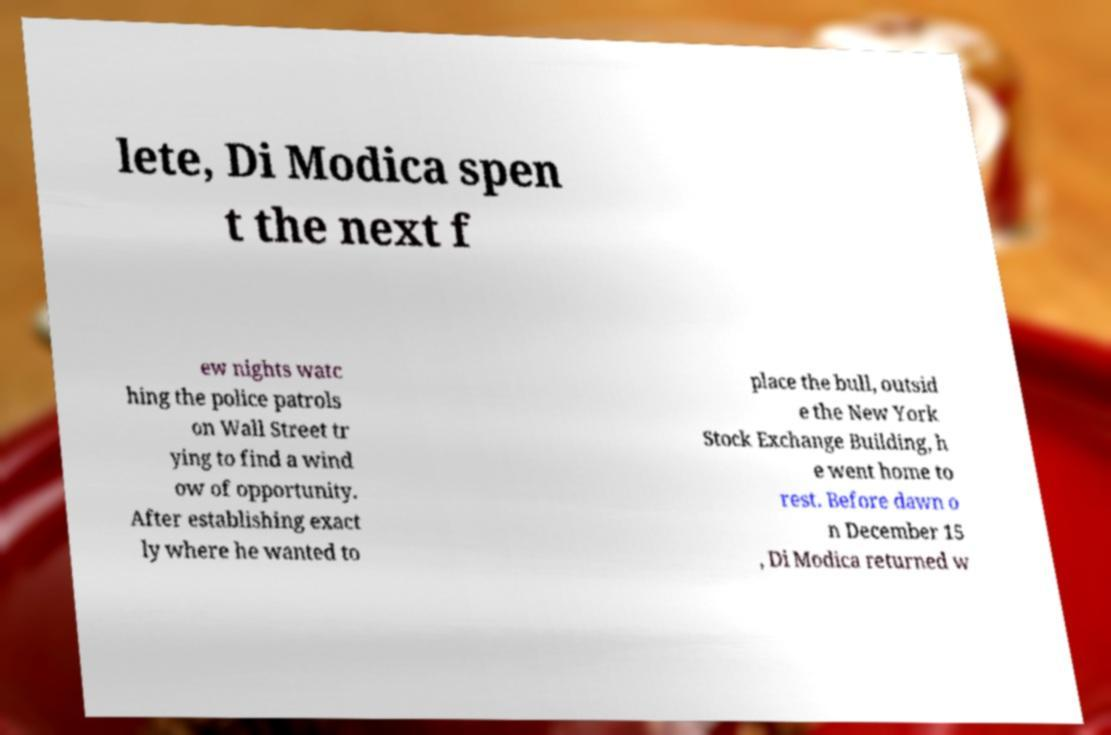Could you extract and type out the text from this image? lete, Di Modica spen t the next f ew nights watc hing the police patrols on Wall Street tr ying to find a wind ow of opportunity. After establishing exact ly where he wanted to place the bull, outsid e the New York Stock Exchange Building, h e went home to rest. Before dawn o n December 15 , Di Modica returned w 